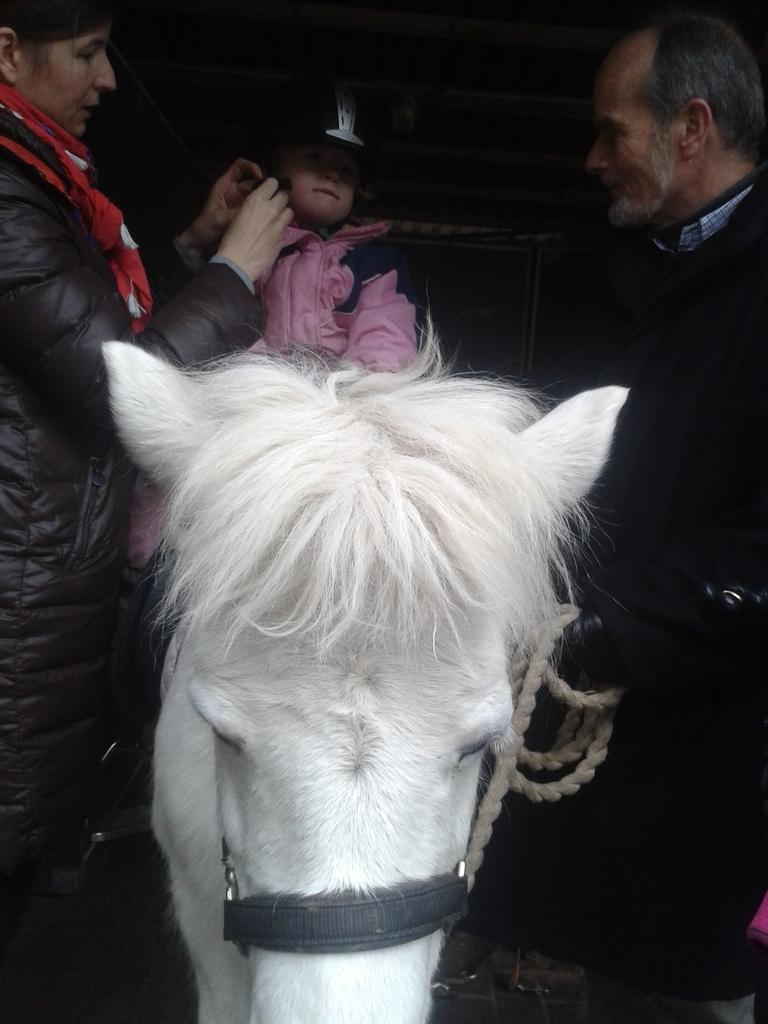What is the boy doing in the image? The boy is sitting on a horse. What color is the horse in the image? The horse is white in color. Who else is present in the image besides the boy? There is a man and a woman standing beside the horse. What are the man and woman doing in the image? The man and woman are holding the horse. What type of brain surgery is the boy undergoing in the image? There is no indication of brain surgery or any medical procedure in the image; the boy is simply sitting on a horse. 